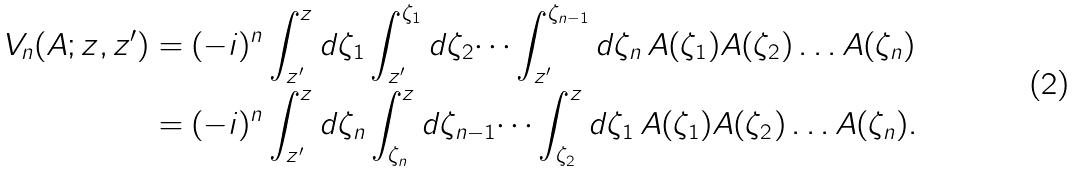<formula> <loc_0><loc_0><loc_500><loc_500>V _ { n } ( A ; z , z ^ { \prime } ) & = ( - i ) ^ { n } \int _ { z ^ { \prime } } ^ { z } d \zeta _ { 1 } \int _ { z ^ { \prime } } ^ { \zeta _ { 1 } } d \zeta _ { 2 } \dots \int _ { z ^ { \prime } } ^ { \zeta _ { n - 1 } } d \zeta _ { n } \, A ( \zeta _ { 1 } ) A ( \zeta _ { 2 } ) \dots A ( \zeta _ { n } ) \\ & = ( - i ) ^ { n } \int _ { z ^ { \prime } } ^ { z } d \zeta _ { n } \int _ { \zeta _ { n } } ^ { z } d \zeta _ { n - 1 } \dots \int _ { \zeta _ { 2 } } ^ { z } d \zeta _ { 1 } \, A ( \zeta _ { 1 } ) A ( \zeta _ { 2 } ) \dots A ( \zeta _ { n } ) .</formula> 